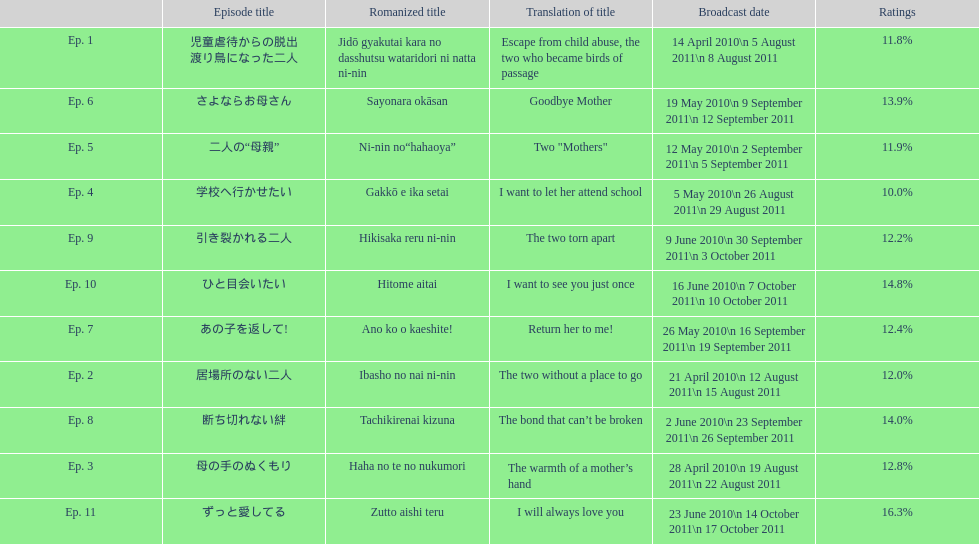What are all the titles the episodes of the mother tv series? 児童虐待からの脱出 渡り鳥になった二人, 居場所のない二人, 母の手のぬくもり, 学校へ行かせたい, 二人の“母親”, さよならお母さん, あの子を返して!, 断ち切れない絆, 引き裂かれる二人, ひと目会いたい, ずっと愛してる. What are all of the ratings for each of the shows? 11.8%, 12.0%, 12.8%, 10.0%, 11.9%, 13.9%, 12.4%, 14.0%, 12.2%, 14.8%, 16.3%. What is the highest score for ratings? 16.3%. What episode corresponds to that rating? ずっと愛してる. 